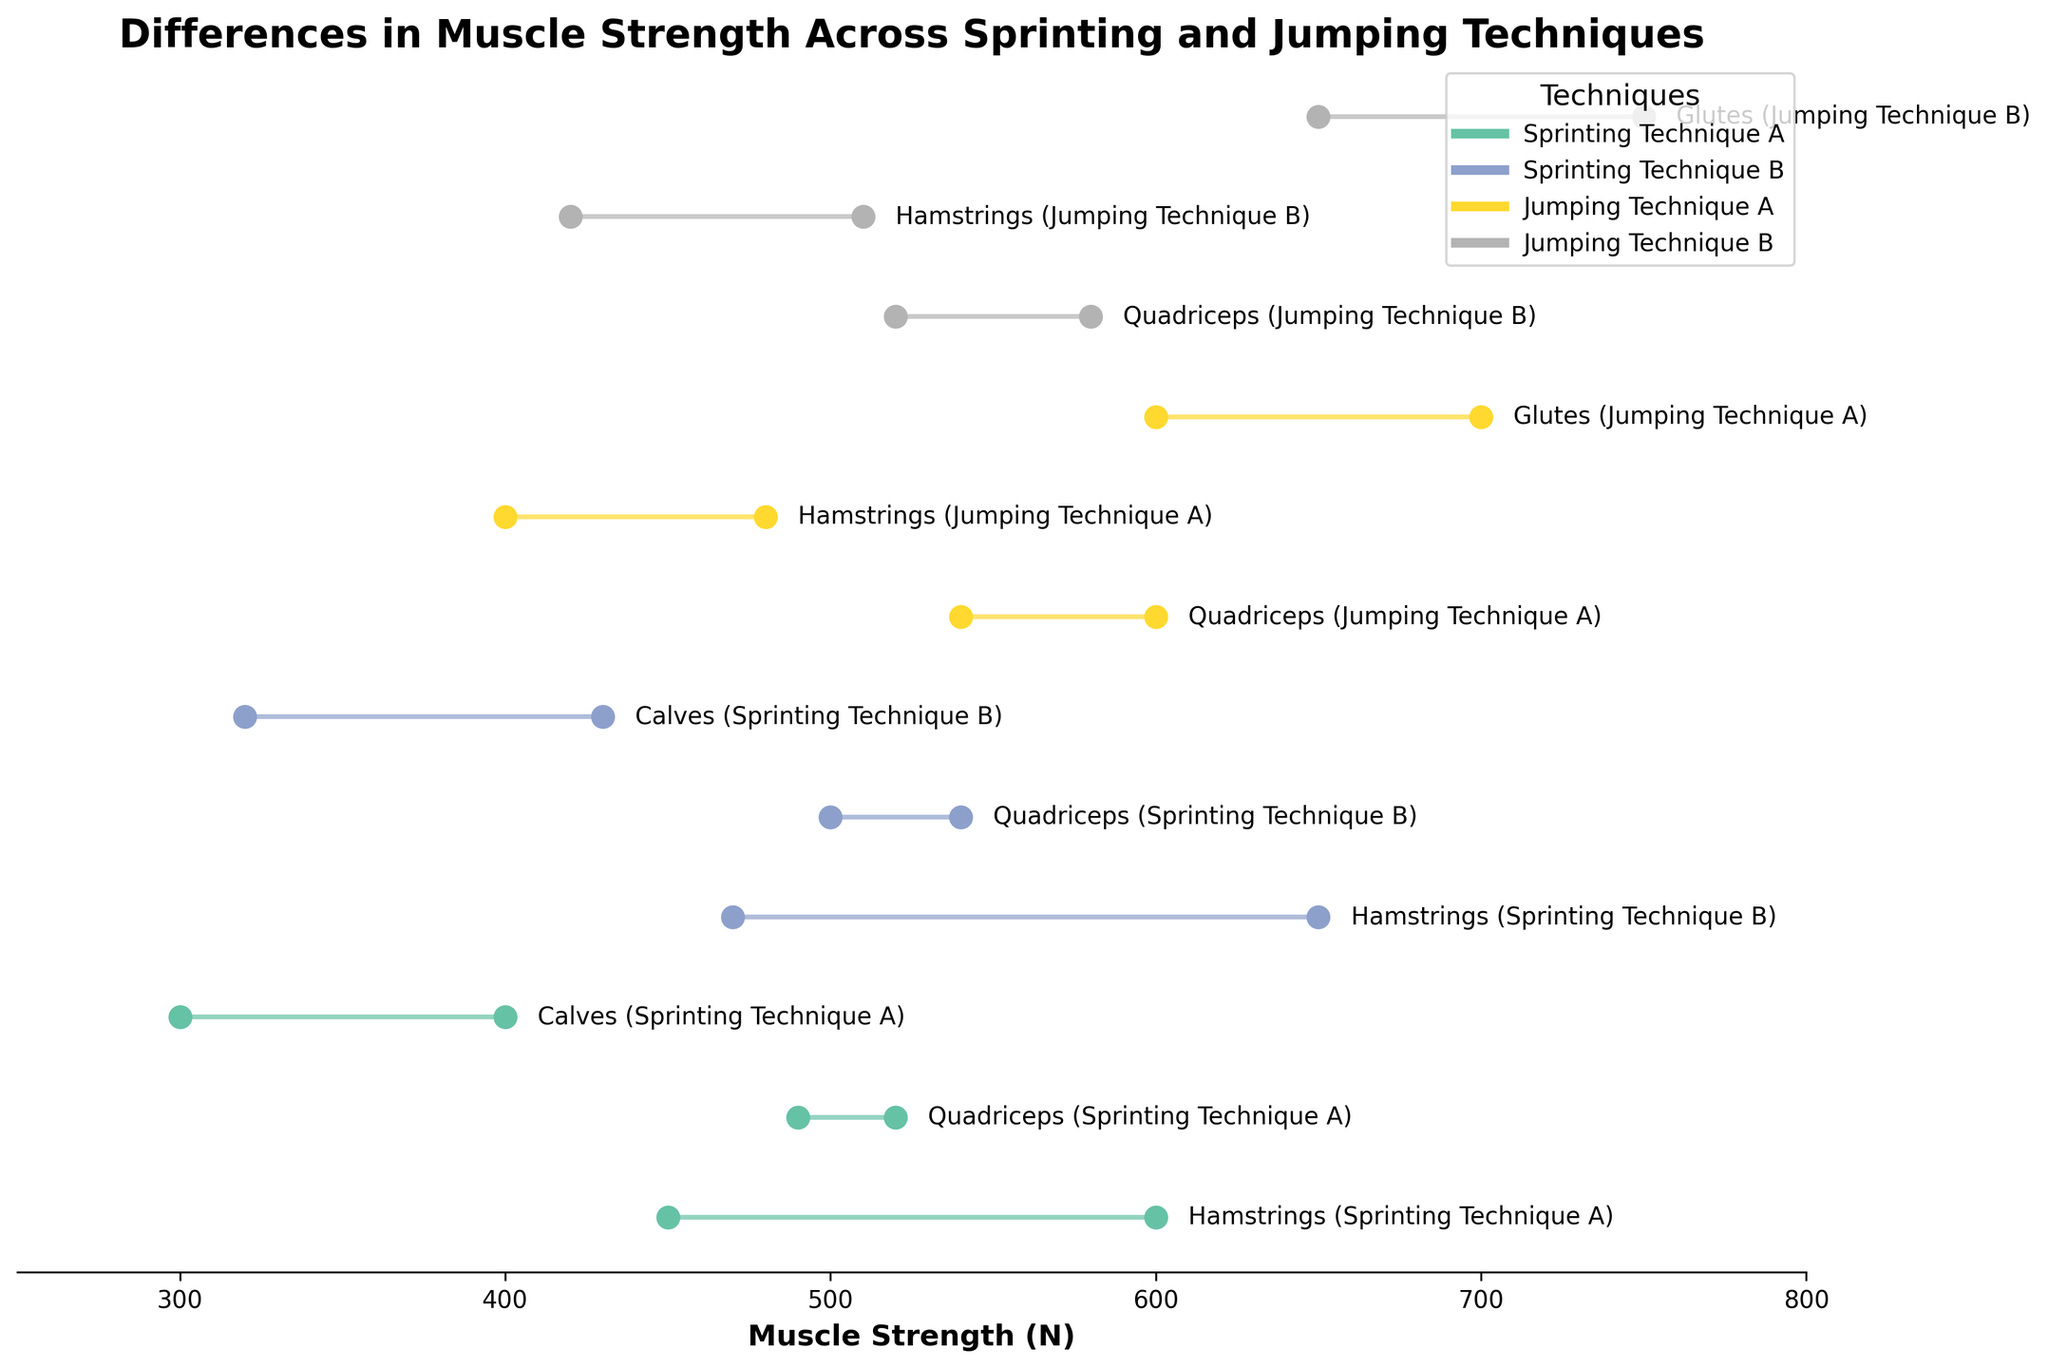What's the maximum muscle strength observed for Sprinting Technique B? The maximum observed strength for Sprinting Technique B is found under the Hamstrings muscle group, represented by the upper end of the ranged dot plot. The highest value there is 650 N.
Answer: 650 N What is the difference in the maximum muscle strength between Jumping Technique B and Sprinting Technique A for the Quadriceps? For Jumping Technique B, the maximum strength of the Quadriceps is 580 N. For Sprinting Technique A, the maximum strength of the Quadriceps is 520 N. The difference is 580 - 520 = 60 N.
Answer: 60 N Which muscle group shows the largest strength range for Sprinting Technique A? The Hamstrings in Sprinting Technique A have the largest range, from 450 to 600 N, giving a range of 150 N.
Answer: Hamstrings Does any muscle group in Jumping Technique A show a higher minimum strength than the maximum strength of Calves in Sprinting Technique A? If so, which one? The minimum strength for the Calves in Sprinting Technique A is 300 N and the maximum strength is 400 N. Both the Quadriceps (min: 540 N) and Glutes (min: 600 N) in Jumping Technique A show higher minimum strengths.
Answer: Quadriceps and Glutes Which muscle group has the tightest strength range for Jumping Technique B? The Quadriceps in Jumping Technique B have the tightest range, from 520 to 580 N, giving a range of 60 N.
Answer: Quadriceps Compare the average muscle strength range for the Hamstrings between Sprinting Techniques A and B. Sprinting Technique A Hamstrings: (450+600)/2 = 525 N. Sprinting Technique B Hamstrings: (470+650)/2 = 560 N.
Answer: Technique A: 525 N, Technique B: 560 N What's the collective range of muscle strengths (from minimum to maximum value) observed across all techniques for the Glutes? Jumping Technique A: 600-700 N. Jumping Technique B: 650-750 N. The collective range is from 600 N (min of Technique A) to 750 N (max of Technique B).
Answer: 600-750 N For which technique is the maximum muscle strength of the Calves higher? Sprinting Technique B has a maximum strength of 430 N which is higher than Sprinting Technique A's maximum strength of 400 N.
Answer: Sprinting Technique B 